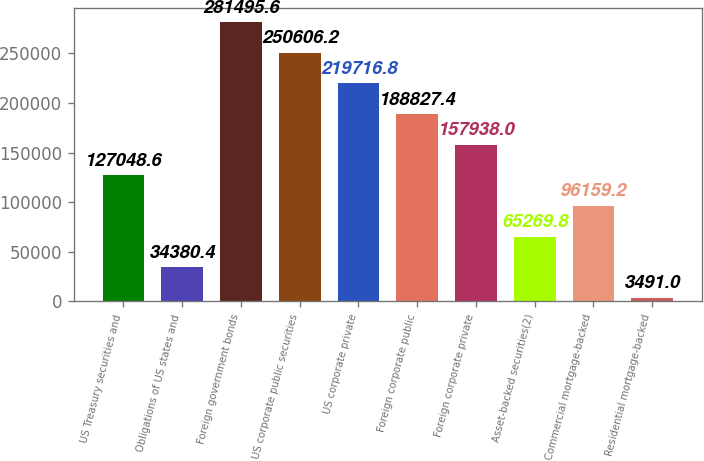Convert chart to OTSL. <chart><loc_0><loc_0><loc_500><loc_500><bar_chart><fcel>US Treasury securities and<fcel>Obligations of US states and<fcel>Foreign government bonds<fcel>US corporate public securities<fcel>US corporate private<fcel>Foreign corporate public<fcel>Foreign corporate private<fcel>Asset-backed securities(2)<fcel>Commercial mortgage-backed<fcel>Residential mortgage-backed<nl><fcel>127049<fcel>34380.4<fcel>281496<fcel>250606<fcel>219717<fcel>188827<fcel>157938<fcel>65269.8<fcel>96159.2<fcel>3491<nl></chart> 